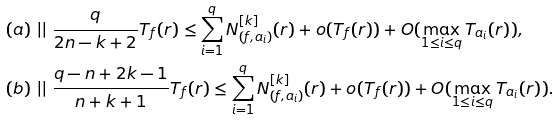Convert formula to latex. <formula><loc_0><loc_0><loc_500><loc_500>& ( a ) \ | | \ \frac { q } { 2 n - k + 2 } T _ { f } ( r ) \leq \sum _ { i = 1 } ^ { q } N _ { ( f , a _ { i } ) } ^ { [ k ] } ( r ) + o ( T _ { f } ( r ) ) + O ( \max _ { 1 \leq i \leq q } T _ { a _ { i } } ( r ) ) , \\ & ( b ) \ | | \ \frac { q - n + 2 k - 1 } { n + k + 1 } T _ { f } ( r ) \leq \sum _ { i = 1 } ^ { q } N _ { ( f , a _ { i } ) } ^ { [ k ] } ( r ) + o ( T _ { f } ( r ) ) + O ( \max _ { 1 \leq i \leq q } T _ { a _ { i } } ( r ) ) .</formula> 